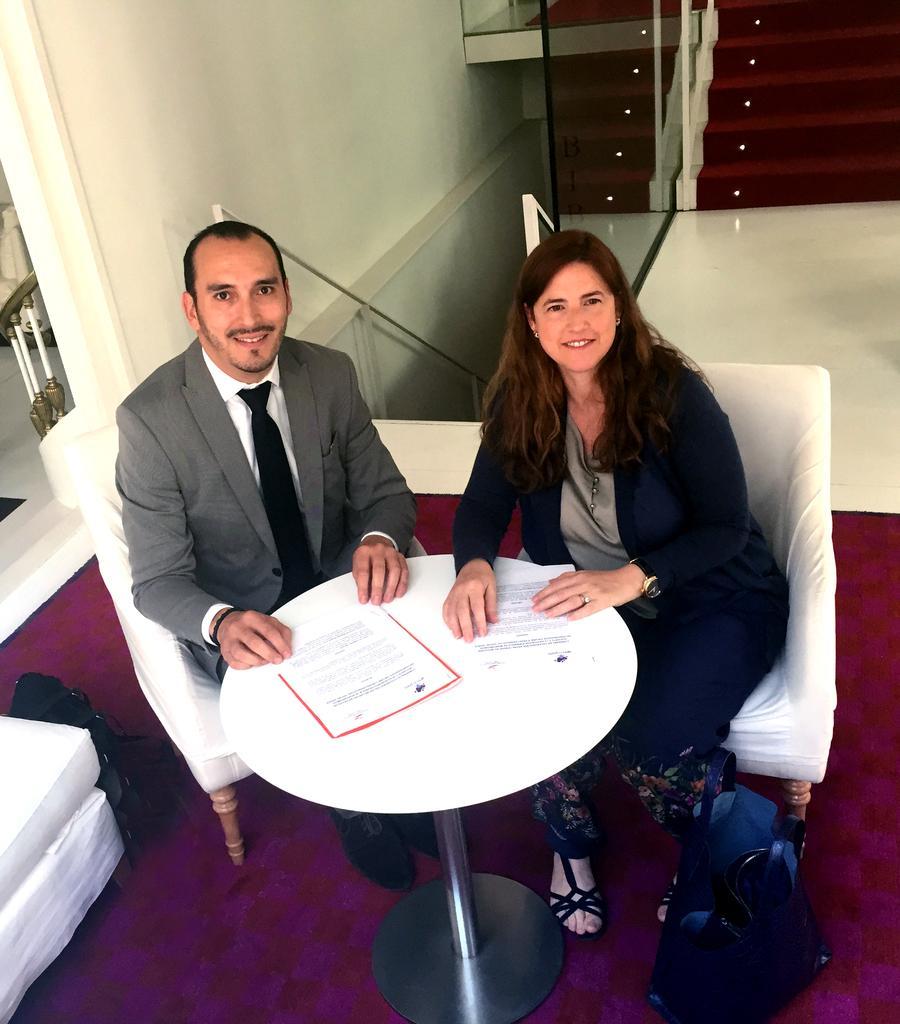Could you give a brief overview of what you see in this image? In the center of the image we can see two people are sitting on the chairs and they are smiling. In front of them, we can see the table. On the table, we can see the papers. And we can see one chair, bags, one carpet and a few other objects. In the background there is a wall, glass, fences and a few other objects. 